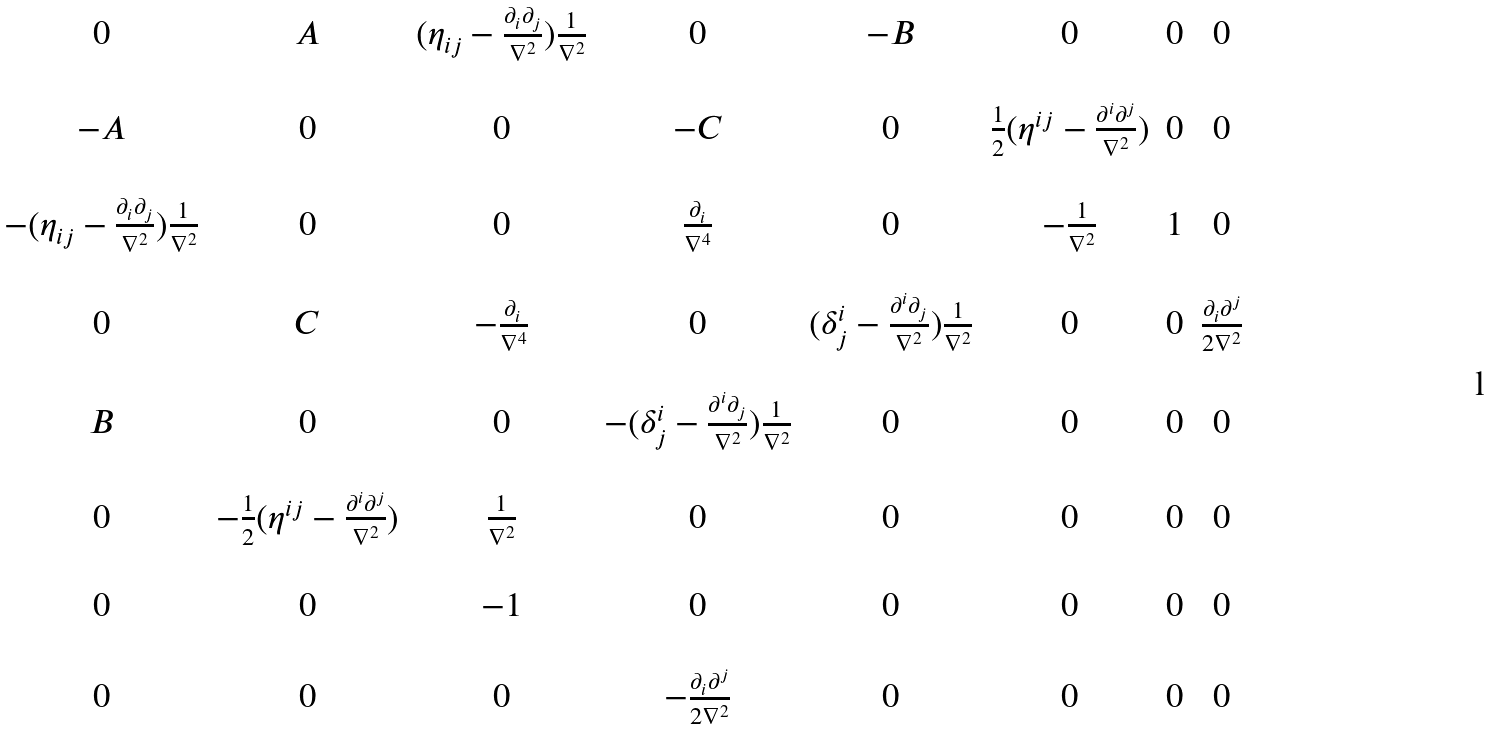<formula> <loc_0><loc_0><loc_500><loc_500>\begin{matrix} 0 & A & ( \eta _ { i j } - \frac { \partial _ { i } \partial _ { j } } { \nabla ^ { 2 } } ) \frac { 1 } { \nabla ^ { 2 } } & 0 & - B & 0 & 0 & 0 \\ \\ - A & 0 & 0 & - C & 0 & \frac { 1 } { 2 } ( \eta ^ { i j } - \frac { \partial ^ { i } \partial ^ { j } } { \nabla ^ { 2 } } ) & 0 & 0 \\ \\ - ( \eta _ { i j } - \frac { \partial _ { i } \partial _ { j } } { \nabla ^ { 2 } } ) \frac { 1 } { \nabla ^ { 2 } } & 0 & 0 & \frac { \partial _ { i } } { \nabla ^ { 4 } } & 0 & - \frac { 1 } { \nabla ^ { 2 } } & 1 & 0 \\ \\ 0 & C & - \frac { \partial _ { i } } { \nabla ^ { 4 } } & 0 & ( \delta ^ { i } _ { j } - \frac { \partial ^ { i } \partial _ { j } } { \nabla ^ { 2 } } ) \frac { 1 } { \nabla ^ { 2 } } & 0 & 0 & \frac { \partial _ { i } \partial ^ { j } } { 2 \nabla ^ { 2 } } \\ \\ B & 0 & 0 & - ( \delta ^ { i } _ { j } - \frac { \partial ^ { i } \partial _ { j } } { \nabla ^ { 2 } } ) \frac { 1 } { \nabla ^ { 2 } } & 0 & 0 & 0 & 0 \\ \\ 0 & - \frac { 1 } { 2 } ( \eta ^ { i j } - \frac { \partial ^ { i } \partial ^ { j } } { \nabla ^ { 2 } } ) & \frac { 1 } { \nabla ^ { 2 } } & 0 & 0 & 0 & 0 & 0 \\ \\ 0 & 0 & - 1 & 0 & 0 & 0 & 0 & 0 \\ \\ 0 & 0 & 0 & - \frac { \partial _ { i } \partial ^ { j } } { 2 \nabla ^ { 2 } } & 0 & 0 & 0 & 0 \\ \\ \end{matrix}</formula> 